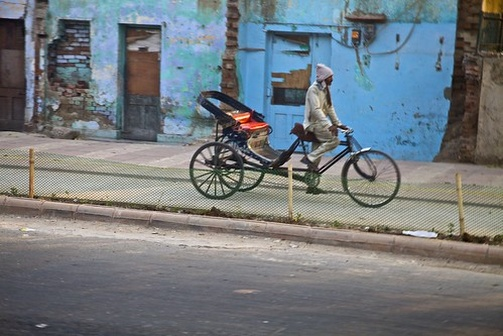Analyze the image in a comprehensive and detailed manner. In the image, a man is engaging in riding a tricycle down a street in an urban area. The tricycle is vividly painted red and features a robust, spacious basket attached to its rear. The man, who is dressed in casual clothes, is seen taking safety measures by wearing a white helmet.

The street itself is enclosed by a variety of buildings. The most notable of these structures is a blue building in a state of visible disrepair, situated behind a green fence. In front of this dilapidated building, the sidewalk is strewn with various discarded items, indicating that the area may be neglected or in need of cleaning.

This scene captures a slice of city life, highlighting the man’s daily routine against the backdrop of an urban landscape marked by the passage of time and change. 